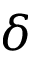Convert formula to latex. <formula><loc_0><loc_0><loc_500><loc_500>\delta</formula> 